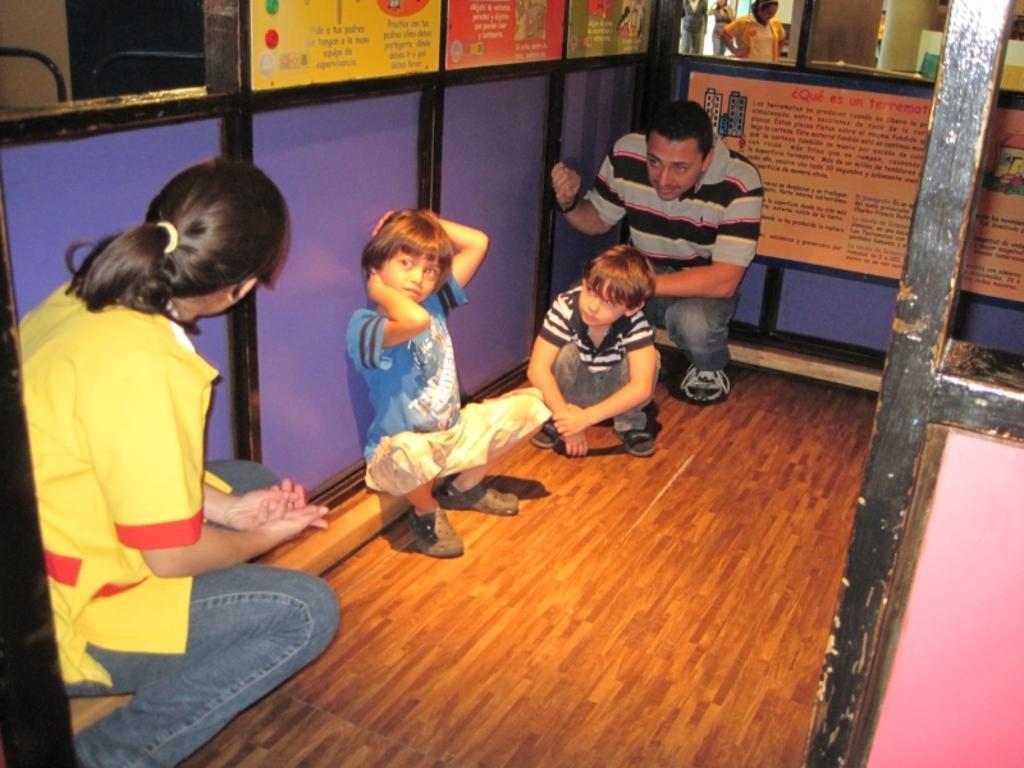Describe this image in one or two sentences. In this image in the center there are persons sitting and there are boards with some text written on it. In the background there is a mirror and on the mirror there is a reflection of the person. On the right side there is a stand. 